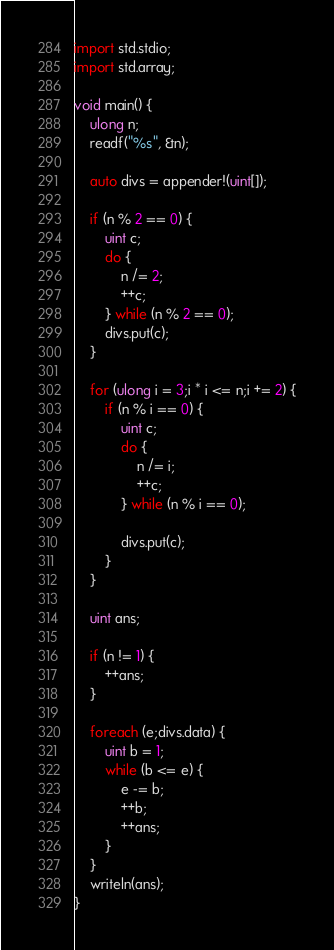Convert code to text. <code><loc_0><loc_0><loc_500><loc_500><_D_>import std.stdio;
import std.array;

void main() {
	ulong n;
	readf("%s", &n);

	auto divs = appender!(uint[]);

	if (n % 2 == 0) {
		uint c;
		do {
			n /= 2;
			++c;
		} while (n % 2 == 0);
		divs.put(c);
	}

	for (ulong i = 3;i * i <= n;i += 2) {
		if (n % i == 0) {
			uint c;
			do {
				n /= i;
				++c;
			} while (n % i == 0);

			divs.put(c);
		}
	}

	uint ans;

	if (n != 1) {
		++ans;
	}

	foreach (e;divs.data) {
		uint b = 1;
		while (b <= e) {
			e -= b;
			++b;
			++ans;
		}
	}
	writeln(ans);
}
</code> 